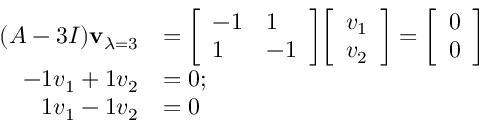<formula> <loc_0><loc_0><loc_500><loc_500>{ \begin{array} { r l } { ( A - 3 I ) v _ { \lambda = 3 } } & { = { \left [ \begin{array} { l l } { - 1 } & { 1 } \\ { 1 } & { - 1 } \end{array} \right ] } { \left [ \begin{array} { l } { v _ { 1 } } \\ { v _ { 2 } } \end{array} \right ] } = { \left [ \begin{array} { l } { 0 } \\ { 0 } \end{array} \right ] } } \\ { - 1 v _ { 1 } + 1 v _ { 2 } } & { = 0 ; } \\ { 1 v _ { 1 } - 1 v _ { 2 } } & { = 0 } \end{array} }</formula> 